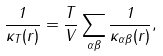<formula> <loc_0><loc_0><loc_500><loc_500>\frac { 1 } { \kappa _ { T } ( { r } ) } = \frac { T } { V } \sum _ { \alpha \beta } \frac { 1 } { \kappa _ { \alpha \beta } ( { r } ) } ,</formula> 